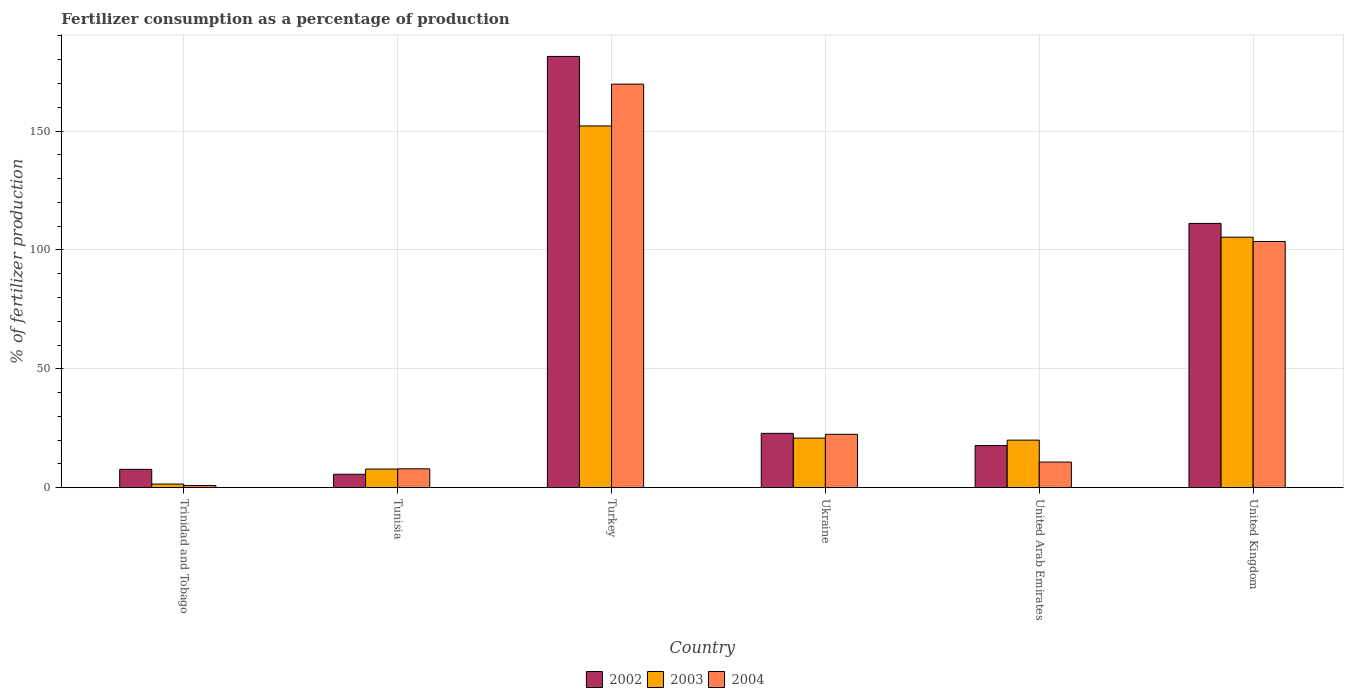How many groups of bars are there?
Your answer should be compact. 6. Are the number of bars on each tick of the X-axis equal?
Your answer should be very brief. Yes. How many bars are there on the 2nd tick from the right?
Your answer should be compact. 3. What is the label of the 6th group of bars from the left?
Give a very brief answer. United Kingdom. What is the percentage of fertilizers consumed in 2002 in Ukraine?
Make the answer very short. 22.84. Across all countries, what is the maximum percentage of fertilizers consumed in 2004?
Your response must be concise. 169.74. Across all countries, what is the minimum percentage of fertilizers consumed in 2003?
Provide a short and direct response. 1.52. In which country was the percentage of fertilizers consumed in 2002 minimum?
Provide a succinct answer. Tunisia. What is the total percentage of fertilizers consumed in 2004 in the graph?
Offer a very short reply. 315.3. What is the difference between the percentage of fertilizers consumed in 2003 in Tunisia and that in Ukraine?
Offer a terse response. -13.02. What is the difference between the percentage of fertilizers consumed in 2004 in Ukraine and the percentage of fertilizers consumed in 2002 in Turkey?
Ensure brevity in your answer.  -158.96. What is the average percentage of fertilizers consumed in 2003 per country?
Your answer should be very brief. 51.28. What is the difference between the percentage of fertilizers consumed of/in 2002 and percentage of fertilizers consumed of/in 2004 in Ukraine?
Make the answer very short. 0.4. In how many countries, is the percentage of fertilizers consumed in 2002 greater than 40 %?
Your answer should be very brief. 2. What is the ratio of the percentage of fertilizers consumed in 2002 in Tunisia to that in Ukraine?
Make the answer very short. 0.25. What is the difference between the highest and the second highest percentage of fertilizers consumed in 2004?
Keep it short and to the point. 147.31. What is the difference between the highest and the lowest percentage of fertilizers consumed in 2003?
Give a very brief answer. 150.64. In how many countries, is the percentage of fertilizers consumed in 2004 greater than the average percentage of fertilizers consumed in 2004 taken over all countries?
Provide a short and direct response. 2. Is the sum of the percentage of fertilizers consumed in 2003 in United Arab Emirates and United Kingdom greater than the maximum percentage of fertilizers consumed in 2002 across all countries?
Your answer should be compact. No. What does the 3rd bar from the left in Trinidad and Tobago represents?
Make the answer very short. 2004. Are all the bars in the graph horizontal?
Provide a succinct answer. No. What is the difference between two consecutive major ticks on the Y-axis?
Offer a very short reply. 50. Does the graph contain any zero values?
Your response must be concise. No. How many legend labels are there?
Your answer should be very brief. 3. What is the title of the graph?
Your answer should be compact. Fertilizer consumption as a percentage of production. What is the label or title of the Y-axis?
Offer a very short reply. % of fertilizer production. What is the % of fertilizer production of 2002 in Trinidad and Tobago?
Ensure brevity in your answer.  7.7. What is the % of fertilizer production of 2003 in Trinidad and Tobago?
Provide a succinct answer. 1.52. What is the % of fertilizer production in 2004 in Trinidad and Tobago?
Provide a succinct answer. 0.88. What is the % of fertilizer production of 2002 in Tunisia?
Provide a succinct answer. 5.63. What is the % of fertilizer production of 2003 in Tunisia?
Keep it short and to the point. 7.82. What is the % of fertilizer production in 2004 in Tunisia?
Keep it short and to the point. 7.92. What is the % of fertilizer production in 2002 in Turkey?
Provide a short and direct response. 181.4. What is the % of fertilizer production of 2003 in Turkey?
Your answer should be very brief. 152.16. What is the % of fertilizer production in 2004 in Turkey?
Provide a succinct answer. 169.74. What is the % of fertilizer production of 2002 in Ukraine?
Provide a short and direct response. 22.84. What is the % of fertilizer production of 2003 in Ukraine?
Keep it short and to the point. 20.84. What is the % of fertilizer production in 2004 in Ukraine?
Your response must be concise. 22.44. What is the % of fertilizer production of 2002 in United Arab Emirates?
Give a very brief answer. 17.71. What is the % of fertilizer production in 2003 in United Arab Emirates?
Your answer should be very brief. 19.98. What is the % of fertilizer production of 2004 in United Arab Emirates?
Offer a terse response. 10.77. What is the % of fertilizer production of 2002 in United Kingdom?
Provide a succinct answer. 111.16. What is the % of fertilizer production of 2003 in United Kingdom?
Ensure brevity in your answer.  105.36. What is the % of fertilizer production of 2004 in United Kingdom?
Offer a terse response. 103.55. Across all countries, what is the maximum % of fertilizer production in 2002?
Your answer should be very brief. 181.4. Across all countries, what is the maximum % of fertilizer production in 2003?
Provide a succinct answer. 152.16. Across all countries, what is the maximum % of fertilizer production in 2004?
Ensure brevity in your answer.  169.74. Across all countries, what is the minimum % of fertilizer production in 2002?
Provide a succinct answer. 5.63. Across all countries, what is the minimum % of fertilizer production in 2003?
Offer a very short reply. 1.52. Across all countries, what is the minimum % of fertilizer production of 2004?
Give a very brief answer. 0.88. What is the total % of fertilizer production of 2002 in the graph?
Offer a terse response. 346.43. What is the total % of fertilizer production of 2003 in the graph?
Give a very brief answer. 307.69. What is the total % of fertilizer production in 2004 in the graph?
Keep it short and to the point. 315.3. What is the difference between the % of fertilizer production in 2002 in Trinidad and Tobago and that in Tunisia?
Your answer should be very brief. 2.07. What is the difference between the % of fertilizer production in 2003 in Trinidad and Tobago and that in Tunisia?
Give a very brief answer. -6.3. What is the difference between the % of fertilizer production of 2004 in Trinidad and Tobago and that in Tunisia?
Your answer should be very brief. -7.04. What is the difference between the % of fertilizer production of 2002 in Trinidad and Tobago and that in Turkey?
Your response must be concise. -173.7. What is the difference between the % of fertilizer production in 2003 in Trinidad and Tobago and that in Turkey?
Keep it short and to the point. -150.64. What is the difference between the % of fertilizer production in 2004 in Trinidad and Tobago and that in Turkey?
Ensure brevity in your answer.  -168.86. What is the difference between the % of fertilizer production in 2002 in Trinidad and Tobago and that in Ukraine?
Make the answer very short. -15.14. What is the difference between the % of fertilizer production in 2003 in Trinidad and Tobago and that in Ukraine?
Your answer should be compact. -19.33. What is the difference between the % of fertilizer production of 2004 in Trinidad and Tobago and that in Ukraine?
Offer a very short reply. -21.56. What is the difference between the % of fertilizer production of 2002 in Trinidad and Tobago and that in United Arab Emirates?
Offer a terse response. -10.01. What is the difference between the % of fertilizer production of 2003 in Trinidad and Tobago and that in United Arab Emirates?
Keep it short and to the point. -18.47. What is the difference between the % of fertilizer production of 2004 in Trinidad and Tobago and that in United Arab Emirates?
Your response must be concise. -9.9. What is the difference between the % of fertilizer production in 2002 in Trinidad and Tobago and that in United Kingdom?
Keep it short and to the point. -103.46. What is the difference between the % of fertilizer production in 2003 in Trinidad and Tobago and that in United Kingdom?
Ensure brevity in your answer.  -103.85. What is the difference between the % of fertilizer production of 2004 in Trinidad and Tobago and that in United Kingdom?
Provide a short and direct response. -102.67. What is the difference between the % of fertilizer production in 2002 in Tunisia and that in Turkey?
Provide a short and direct response. -175.77. What is the difference between the % of fertilizer production of 2003 in Tunisia and that in Turkey?
Keep it short and to the point. -144.34. What is the difference between the % of fertilizer production of 2004 in Tunisia and that in Turkey?
Your answer should be very brief. -161.82. What is the difference between the % of fertilizer production of 2002 in Tunisia and that in Ukraine?
Provide a short and direct response. -17.21. What is the difference between the % of fertilizer production of 2003 in Tunisia and that in Ukraine?
Your response must be concise. -13.02. What is the difference between the % of fertilizer production in 2004 in Tunisia and that in Ukraine?
Your response must be concise. -14.52. What is the difference between the % of fertilizer production of 2002 in Tunisia and that in United Arab Emirates?
Give a very brief answer. -12.08. What is the difference between the % of fertilizer production in 2003 in Tunisia and that in United Arab Emirates?
Ensure brevity in your answer.  -12.16. What is the difference between the % of fertilizer production of 2004 in Tunisia and that in United Arab Emirates?
Provide a short and direct response. -2.85. What is the difference between the % of fertilizer production of 2002 in Tunisia and that in United Kingdom?
Make the answer very short. -105.53. What is the difference between the % of fertilizer production of 2003 in Tunisia and that in United Kingdom?
Your answer should be very brief. -97.55. What is the difference between the % of fertilizer production of 2004 in Tunisia and that in United Kingdom?
Ensure brevity in your answer.  -95.63. What is the difference between the % of fertilizer production of 2002 in Turkey and that in Ukraine?
Your response must be concise. 158.56. What is the difference between the % of fertilizer production in 2003 in Turkey and that in Ukraine?
Your response must be concise. 131.32. What is the difference between the % of fertilizer production of 2004 in Turkey and that in Ukraine?
Keep it short and to the point. 147.31. What is the difference between the % of fertilizer production of 2002 in Turkey and that in United Arab Emirates?
Ensure brevity in your answer.  163.69. What is the difference between the % of fertilizer production of 2003 in Turkey and that in United Arab Emirates?
Offer a terse response. 132.18. What is the difference between the % of fertilizer production of 2004 in Turkey and that in United Arab Emirates?
Your response must be concise. 158.97. What is the difference between the % of fertilizer production in 2002 in Turkey and that in United Kingdom?
Make the answer very short. 70.24. What is the difference between the % of fertilizer production of 2003 in Turkey and that in United Kingdom?
Make the answer very short. 46.8. What is the difference between the % of fertilizer production in 2004 in Turkey and that in United Kingdom?
Your answer should be very brief. 66.19. What is the difference between the % of fertilizer production in 2002 in Ukraine and that in United Arab Emirates?
Provide a succinct answer. 5.13. What is the difference between the % of fertilizer production of 2003 in Ukraine and that in United Arab Emirates?
Ensure brevity in your answer.  0.86. What is the difference between the % of fertilizer production in 2004 in Ukraine and that in United Arab Emirates?
Ensure brevity in your answer.  11.66. What is the difference between the % of fertilizer production in 2002 in Ukraine and that in United Kingdom?
Keep it short and to the point. -88.32. What is the difference between the % of fertilizer production in 2003 in Ukraine and that in United Kingdom?
Ensure brevity in your answer.  -84.52. What is the difference between the % of fertilizer production in 2004 in Ukraine and that in United Kingdom?
Offer a very short reply. -81.11. What is the difference between the % of fertilizer production in 2002 in United Arab Emirates and that in United Kingdom?
Your response must be concise. -93.45. What is the difference between the % of fertilizer production in 2003 in United Arab Emirates and that in United Kingdom?
Provide a short and direct response. -85.38. What is the difference between the % of fertilizer production in 2004 in United Arab Emirates and that in United Kingdom?
Provide a succinct answer. -92.78. What is the difference between the % of fertilizer production in 2002 in Trinidad and Tobago and the % of fertilizer production in 2003 in Tunisia?
Your response must be concise. -0.12. What is the difference between the % of fertilizer production in 2002 in Trinidad and Tobago and the % of fertilizer production in 2004 in Tunisia?
Keep it short and to the point. -0.22. What is the difference between the % of fertilizer production of 2003 in Trinidad and Tobago and the % of fertilizer production of 2004 in Tunisia?
Your answer should be very brief. -6.4. What is the difference between the % of fertilizer production of 2002 in Trinidad and Tobago and the % of fertilizer production of 2003 in Turkey?
Your response must be concise. -144.46. What is the difference between the % of fertilizer production in 2002 in Trinidad and Tobago and the % of fertilizer production in 2004 in Turkey?
Provide a succinct answer. -162.04. What is the difference between the % of fertilizer production of 2003 in Trinidad and Tobago and the % of fertilizer production of 2004 in Turkey?
Offer a terse response. -168.22. What is the difference between the % of fertilizer production of 2002 in Trinidad and Tobago and the % of fertilizer production of 2003 in Ukraine?
Keep it short and to the point. -13.14. What is the difference between the % of fertilizer production in 2002 in Trinidad and Tobago and the % of fertilizer production in 2004 in Ukraine?
Offer a very short reply. -14.74. What is the difference between the % of fertilizer production in 2003 in Trinidad and Tobago and the % of fertilizer production in 2004 in Ukraine?
Offer a terse response. -20.92. What is the difference between the % of fertilizer production in 2002 in Trinidad and Tobago and the % of fertilizer production in 2003 in United Arab Emirates?
Offer a very short reply. -12.29. What is the difference between the % of fertilizer production in 2002 in Trinidad and Tobago and the % of fertilizer production in 2004 in United Arab Emirates?
Ensure brevity in your answer.  -3.07. What is the difference between the % of fertilizer production of 2003 in Trinidad and Tobago and the % of fertilizer production of 2004 in United Arab Emirates?
Provide a succinct answer. -9.25. What is the difference between the % of fertilizer production of 2002 in Trinidad and Tobago and the % of fertilizer production of 2003 in United Kingdom?
Make the answer very short. -97.67. What is the difference between the % of fertilizer production of 2002 in Trinidad and Tobago and the % of fertilizer production of 2004 in United Kingdom?
Provide a succinct answer. -95.85. What is the difference between the % of fertilizer production of 2003 in Trinidad and Tobago and the % of fertilizer production of 2004 in United Kingdom?
Offer a terse response. -102.03. What is the difference between the % of fertilizer production in 2002 in Tunisia and the % of fertilizer production in 2003 in Turkey?
Offer a terse response. -146.53. What is the difference between the % of fertilizer production of 2002 in Tunisia and the % of fertilizer production of 2004 in Turkey?
Provide a short and direct response. -164.12. What is the difference between the % of fertilizer production in 2003 in Tunisia and the % of fertilizer production in 2004 in Turkey?
Provide a short and direct response. -161.92. What is the difference between the % of fertilizer production of 2002 in Tunisia and the % of fertilizer production of 2003 in Ukraine?
Offer a terse response. -15.22. What is the difference between the % of fertilizer production in 2002 in Tunisia and the % of fertilizer production in 2004 in Ukraine?
Your answer should be very brief. -16.81. What is the difference between the % of fertilizer production of 2003 in Tunisia and the % of fertilizer production of 2004 in Ukraine?
Make the answer very short. -14.62. What is the difference between the % of fertilizer production in 2002 in Tunisia and the % of fertilizer production in 2003 in United Arab Emirates?
Offer a very short reply. -14.36. What is the difference between the % of fertilizer production in 2002 in Tunisia and the % of fertilizer production in 2004 in United Arab Emirates?
Make the answer very short. -5.15. What is the difference between the % of fertilizer production of 2003 in Tunisia and the % of fertilizer production of 2004 in United Arab Emirates?
Make the answer very short. -2.95. What is the difference between the % of fertilizer production in 2002 in Tunisia and the % of fertilizer production in 2003 in United Kingdom?
Your answer should be compact. -99.74. What is the difference between the % of fertilizer production of 2002 in Tunisia and the % of fertilizer production of 2004 in United Kingdom?
Your response must be concise. -97.92. What is the difference between the % of fertilizer production of 2003 in Tunisia and the % of fertilizer production of 2004 in United Kingdom?
Ensure brevity in your answer.  -95.73. What is the difference between the % of fertilizer production in 2002 in Turkey and the % of fertilizer production in 2003 in Ukraine?
Make the answer very short. 160.55. What is the difference between the % of fertilizer production in 2002 in Turkey and the % of fertilizer production in 2004 in Ukraine?
Give a very brief answer. 158.96. What is the difference between the % of fertilizer production in 2003 in Turkey and the % of fertilizer production in 2004 in Ukraine?
Keep it short and to the point. 129.72. What is the difference between the % of fertilizer production in 2002 in Turkey and the % of fertilizer production in 2003 in United Arab Emirates?
Your answer should be very brief. 161.41. What is the difference between the % of fertilizer production of 2002 in Turkey and the % of fertilizer production of 2004 in United Arab Emirates?
Your answer should be very brief. 170.62. What is the difference between the % of fertilizer production of 2003 in Turkey and the % of fertilizer production of 2004 in United Arab Emirates?
Offer a very short reply. 141.39. What is the difference between the % of fertilizer production of 2002 in Turkey and the % of fertilizer production of 2003 in United Kingdom?
Your answer should be compact. 76.03. What is the difference between the % of fertilizer production of 2002 in Turkey and the % of fertilizer production of 2004 in United Kingdom?
Provide a succinct answer. 77.85. What is the difference between the % of fertilizer production in 2003 in Turkey and the % of fertilizer production in 2004 in United Kingdom?
Make the answer very short. 48.61. What is the difference between the % of fertilizer production of 2002 in Ukraine and the % of fertilizer production of 2003 in United Arab Emirates?
Your answer should be very brief. 2.86. What is the difference between the % of fertilizer production in 2002 in Ukraine and the % of fertilizer production in 2004 in United Arab Emirates?
Provide a short and direct response. 12.07. What is the difference between the % of fertilizer production of 2003 in Ukraine and the % of fertilizer production of 2004 in United Arab Emirates?
Offer a terse response. 10.07. What is the difference between the % of fertilizer production in 2002 in Ukraine and the % of fertilizer production in 2003 in United Kingdom?
Your response must be concise. -82.52. What is the difference between the % of fertilizer production in 2002 in Ukraine and the % of fertilizer production in 2004 in United Kingdom?
Give a very brief answer. -80.71. What is the difference between the % of fertilizer production in 2003 in Ukraine and the % of fertilizer production in 2004 in United Kingdom?
Give a very brief answer. -82.71. What is the difference between the % of fertilizer production in 2002 in United Arab Emirates and the % of fertilizer production in 2003 in United Kingdom?
Offer a terse response. -87.66. What is the difference between the % of fertilizer production in 2002 in United Arab Emirates and the % of fertilizer production in 2004 in United Kingdom?
Provide a short and direct response. -85.84. What is the difference between the % of fertilizer production of 2003 in United Arab Emirates and the % of fertilizer production of 2004 in United Kingdom?
Offer a terse response. -83.56. What is the average % of fertilizer production of 2002 per country?
Ensure brevity in your answer.  57.74. What is the average % of fertilizer production of 2003 per country?
Offer a terse response. 51.28. What is the average % of fertilizer production of 2004 per country?
Ensure brevity in your answer.  52.55. What is the difference between the % of fertilizer production in 2002 and % of fertilizer production in 2003 in Trinidad and Tobago?
Your answer should be compact. 6.18. What is the difference between the % of fertilizer production in 2002 and % of fertilizer production in 2004 in Trinidad and Tobago?
Offer a terse response. 6.82. What is the difference between the % of fertilizer production in 2003 and % of fertilizer production in 2004 in Trinidad and Tobago?
Provide a succinct answer. 0.64. What is the difference between the % of fertilizer production of 2002 and % of fertilizer production of 2003 in Tunisia?
Your answer should be compact. -2.19. What is the difference between the % of fertilizer production in 2002 and % of fertilizer production in 2004 in Tunisia?
Keep it short and to the point. -2.29. What is the difference between the % of fertilizer production of 2003 and % of fertilizer production of 2004 in Tunisia?
Keep it short and to the point. -0.1. What is the difference between the % of fertilizer production in 2002 and % of fertilizer production in 2003 in Turkey?
Offer a very short reply. 29.24. What is the difference between the % of fertilizer production of 2002 and % of fertilizer production of 2004 in Turkey?
Keep it short and to the point. 11.65. What is the difference between the % of fertilizer production in 2003 and % of fertilizer production in 2004 in Turkey?
Provide a succinct answer. -17.58. What is the difference between the % of fertilizer production in 2002 and % of fertilizer production in 2003 in Ukraine?
Keep it short and to the point. 2. What is the difference between the % of fertilizer production in 2002 and % of fertilizer production in 2004 in Ukraine?
Provide a short and direct response. 0.4. What is the difference between the % of fertilizer production in 2003 and % of fertilizer production in 2004 in Ukraine?
Make the answer very short. -1.59. What is the difference between the % of fertilizer production in 2002 and % of fertilizer production in 2003 in United Arab Emirates?
Provide a succinct answer. -2.28. What is the difference between the % of fertilizer production of 2002 and % of fertilizer production of 2004 in United Arab Emirates?
Your response must be concise. 6.93. What is the difference between the % of fertilizer production in 2003 and % of fertilizer production in 2004 in United Arab Emirates?
Ensure brevity in your answer.  9.21. What is the difference between the % of fertilizer production of 2002 and % of fertilizer production of 2003 in United Kingdom?
Make the answer very short. 5.8. What is the difference between the % of fertilizer production in 2002 and % of fertilizer production in 2004 in United Kingdom?
Ensure brevity in your answer.  7.61. What is the difference between the % of fertilizer production in 2003 and % of fertilizer production in 2004 in United Kingdom?
Offer a terse response. 1.82. What is the ratio of the % of fertilizer production of 2002 in Trinidad and Tobago to that in Tunisia?
Ensure brevity in your answer.  1.37. What is the ratio of the % of fertilizer production in 2003 in Trinidad and Tobago to that in Tunisia?
Offer a terse response. 0.19. What is the ratio of the % of fertilizer production of 2004 in Trinidad and Tobago to that in Tunisia?
Ensure brevity in your answer.  0.11. What is the ratio of the % of fertilizer production in 2002 in Trinidad and Tobago to that in Turkey?
Offer a very short reply. 0.04. What is the ratio of the % of fertilizer production of 2004 in Trinidad and Tobago to that in Turkey?
Your answer should be very brief. 0.01. What is the ratio of the % of fertilizer production in 2002 in Trinidad and Tobago to that in Ukraine?
Make the answer very short. 0.34. What is the ratio of the % of fertilizer production in 2003 in Trinidad and Tobago to that in Ukraine?
Provide a succinct answer. 0.07. What is the ratio of the % of fertilizer production of 2004 in Trinidad and Tobago to that in Ukraine?
Your response must be concise. 0.04. What is the ratio of the % of fertilizer production of 2002 in Trinidad and Tobago to that in United Arab Emirates?
Give a very brief answer. 0.43. What is the ratio of the % of fertilizer production of 2003 in Trinidad and Tobago to that in United Arab Emirates?
Provide a succinct answer. 0.08. What is the ratio of the % of fertilizer production in 2004 in Trinidad and Tobago to that in United Arab Emirates?
Your answer should be very brief. 0.08. What is the ratio of the % of fertilizer production in 2002 in Trinidad and Tobago to that in United Kingdom?
Offer a very short reply. 0.07. What is the ratio of the % of fertilizer production of 2003 in Trinidad and Tobago to that in United Kingdom?
Provide a succinct answer. 0.01. What is the ratio of the % of fertilizer production of 2004 in Trinidad and Tobago to that in United Kingdom?
Offer a very short reply. 0.01. What is the ratio of the % of fertilizer production in 2002 in Tunisia to that in Turkey?
Ensure brevity in your answer.  0.03. What is the ratio of the % of fertilizer production in 2003 in Tunisia to that in Turkey?
Offer a very short reply. 0.05. What is the ratio of the % of fertilizer production of 2004 in Tunisia to that in Turkey?
Give a very brief answer. 0.05. What is the ratio of the % of fertilizer production in 2002 in Tunisia to that in Ukraine?
Provide a short and direct response. 0.25. What is the ratio of the % of fertilizer production of 2003 in Tunisia to that in Ukraine?
Keep it short and to the point. 0.38. What is the ratio of the % of fertilizer production of 2004 in Tunisia to that in Ukraine?
Your response must be concise. 0.35. What is the ratio of the % of fertilizer production in 2002 in Tunisia to that in United Arab Emirates?
Keep it short and to the point. 0.32. What is the ratio of the % of fertilizer production in 2003 in Tunisia to that in United Arab Emirates?
Your answer should be very brief. 0.39. What is the ratio of the % of fertilizer production of 2004 in Tunisia to that in United Arab Emirates?
Provide a short and direct response. 0.74. What is the ratio of the % of fertilizer production of 2002 in Tunisia to that in United Kingdom?
Make the answer very short. 0.05. What is the ratio of the % of fertilizer production in 2003 in Tunisia to that in United Kingdom?
Ensure brevity in your answer.  0.07. What is the ratio of the % of fertilizer production of 2004 in Tunisia to that in United Kingdom?
Your response must be concise. 0.08. What is the ratio of the % of fertilizer production of 2002 in Turkey to that in Ukraine?
Offer a terse response. 7.94. What is the ratio of the % of fertilizer production of 2003 in Turkey to that in Ukraine?
Offer a terse response. 7.3. What is the ratio of the % of fertilizer production in 2004 in Turkey to that in Ukraine?
Your answer should be compact. 7.57. What is the ratio of the % of fertilizer production of 2002 in Turkey to that in United Arab Emirates?
Your answer should be very brief. 10.24. What is the ratio of the % of fertilizer production of 2003 in Turkey to that in United Arab Emirates?
Ensure brevity in your answer.  7.61. What is the ratio of the % of fertilizer production of 2004 in Turkey to that in United Arab Emirates?
Give a very brief answer. 15.76. What is the ratio of the % of fertilizer production of 2002 in Turkey to that in United Kingdom?
Make the answer very short. 1.63. What is the ratio of the % of fertilizer production of 2003 in Turkey to that in United Kingdom?
Provide a short and direct response. 1.44. What is the ratio of the % of fertilizer production in 2004 in Turkey to that in United Kingdom?
Provide a short and direct response. 1.64. What is the ratio of the % of fertilizer production of 2002 in Ukraine to that in United Arab Emirates?
Ensure brevity in your answer.  1.29. What is the ratio of the % of fertilizer production of 2003 in Ukraine to that in United Arab Emirates?
Ensure brevity in your answer.  1.04. What is the ratio of the % of fertilizer production in 2004 in Ukraine to that in United Arab Emirates?
Offer a very short reply. 2.08. What is the ratio of the % of fertilizer production of 2002 in Ukraine to that in United Kingdom?
Your response must be concise. 0.21. What is the ratio of the % of fertilizer production of 2003 in Ukraine to that in United Kingdom?
Provide a succinct answer. 0.2. What is the ratio of the % of fertilizer production in 2004 in Ukraine to that in United Kingdom?
Ensure brevity in your answer.  0.22. What is the ratio of the % of fertilizer production in 2002 in United Arab Emirates to that in United Kingdom?
Give a very brief answer. 0.16. What is the ratio of the % of fertilizer production in 2003 in United Arab Emirates to that in United Kingdom?
Offer a terse response. 0.19. What is the ratio of the % of fertilizer production in 2004 in United Arab Emirates to that in United Kingdom?
Ensure brevity in your answer.  0.1. What is the difference between the highest and the second highest % of fertilizer production in 2002?
Make the answer very short. 70.24. What is the difference between the highest and the second highest % of fertilizer production in 2003?
Give a very brief answer. 46.8. What is the difference between the highest and the second highest % of fertilizer production of 2004?
Give a very brief answer. 66.19. What is the difference between the highest and the lowest % of fertilizer production in 2002?
Keep it short and to the point. 175.77. What is the difference between the highest and the lowest % of fertilizer production of 2003?
Your response must be concise. 150.64. What is the difference between the highest and the lowest % of fertilizer production of 2004?
Make the answer very short. 168.86. 